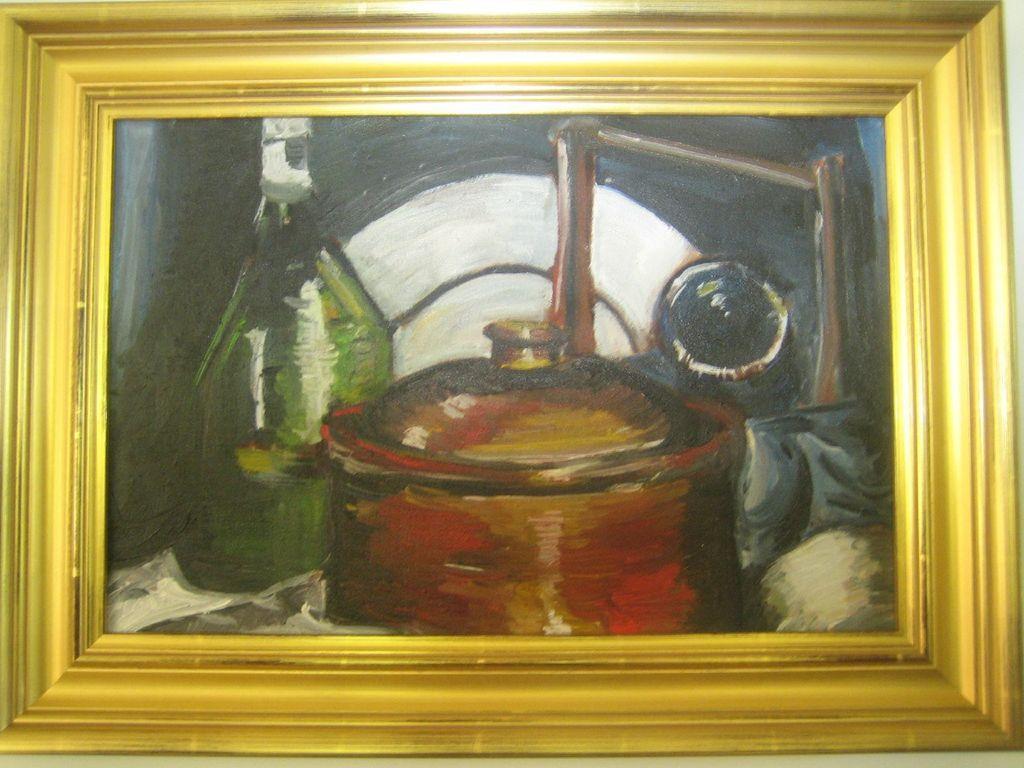Describe this image in one or two sentences. In this image we can see a photo frame with some painting. 